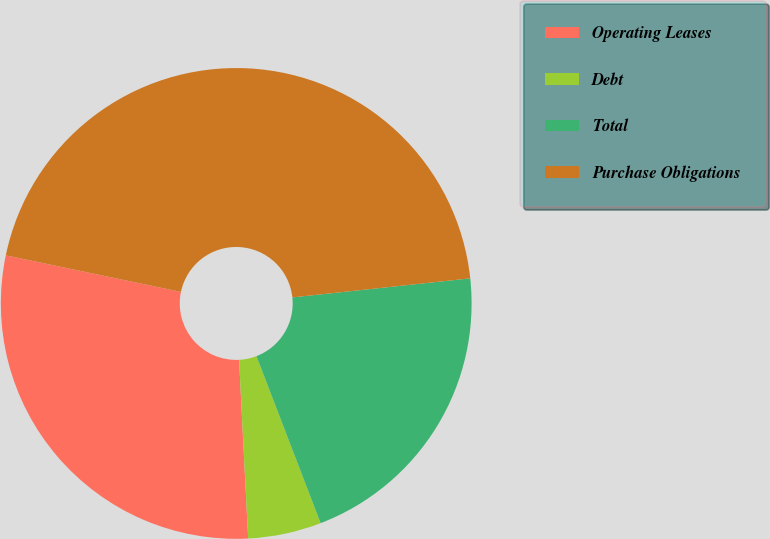<chart> <loc_0><loc_0><loc_500><loc_500><pie_chart><fcel>Operating Leases<fcel>Debt<fcel>Total<fcel>Purchase Obligations<nl><fcel>29.08%<fcel>5.03%<fcel>20.86%<fcel>45.02%<nl></chart> 